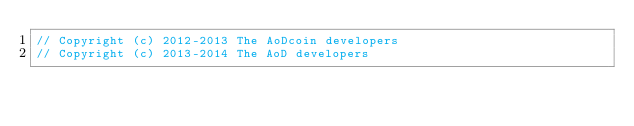<code> <loc_0><loc_0><loc_500><loc_500><_C++_>// Copyright (c) 2012-2013 The AoDcoin developers
// Copyright (c) 2013-2014 The AoD developers</code> 